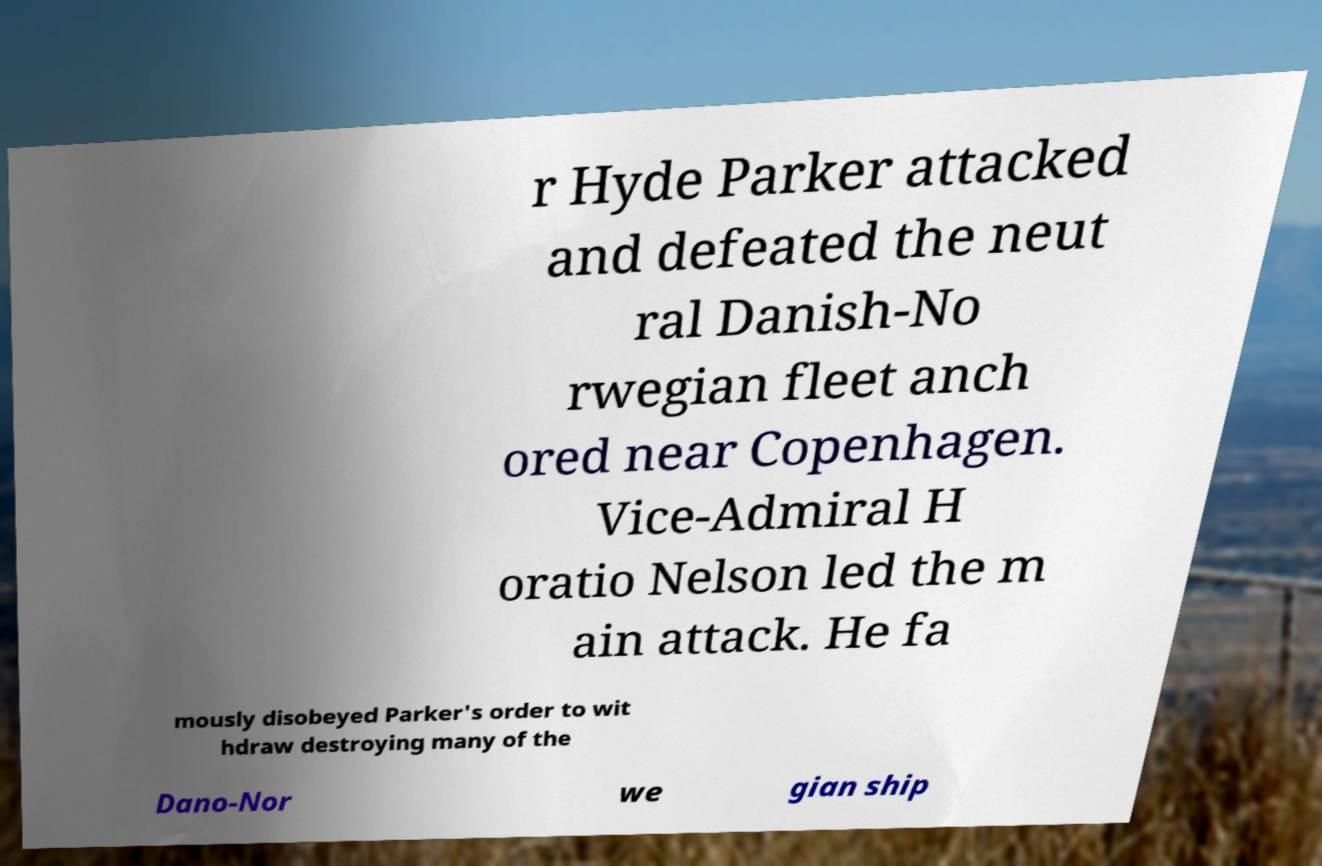Could you extract and type out the text from this image? r Hyde Parker attacked and defeated the neut ral Danish-No rwegian fleet anch ored near Copenhagen. Vice-Admiral H oratio Nelson led the m ain attack. He fa mously disobeyed Parker's order to wit hdraw destroying many of the Dano-Nor we gian ship 